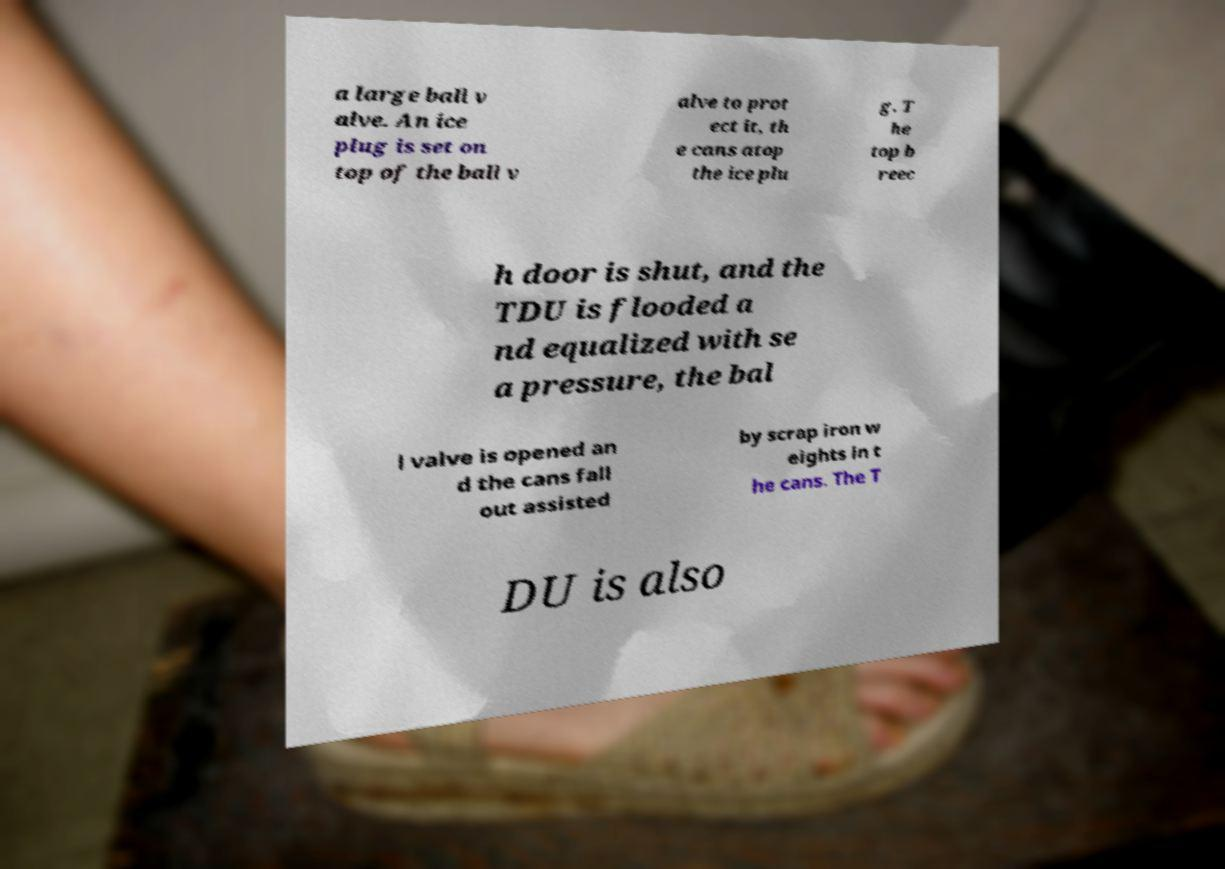Please read and relay the text visible in this image. What does it say? a large ball v alve. An ice plug is set on top of the ball v alve to prot ect it, th e cans atop the ice plu g. T he top b reec h door is shut, and the TDU is flooded a nd equalized with se a pressure, the bal l valve is opened an d the cans fall out assisted by scrap iron w eights in t he cans. The T DU is also 